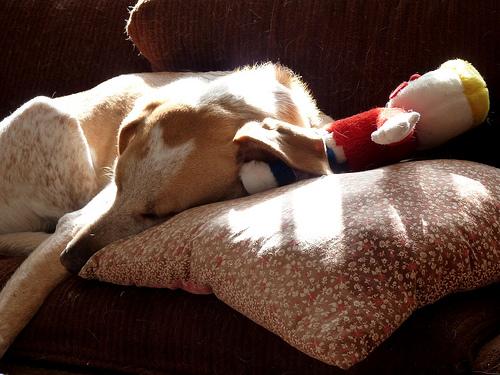<image>
Is there a dog behind the sunlight? No. The dog is not behind the sunlight. From this viewpoint, the dog appears to be positioned elsewhere in the scene. 